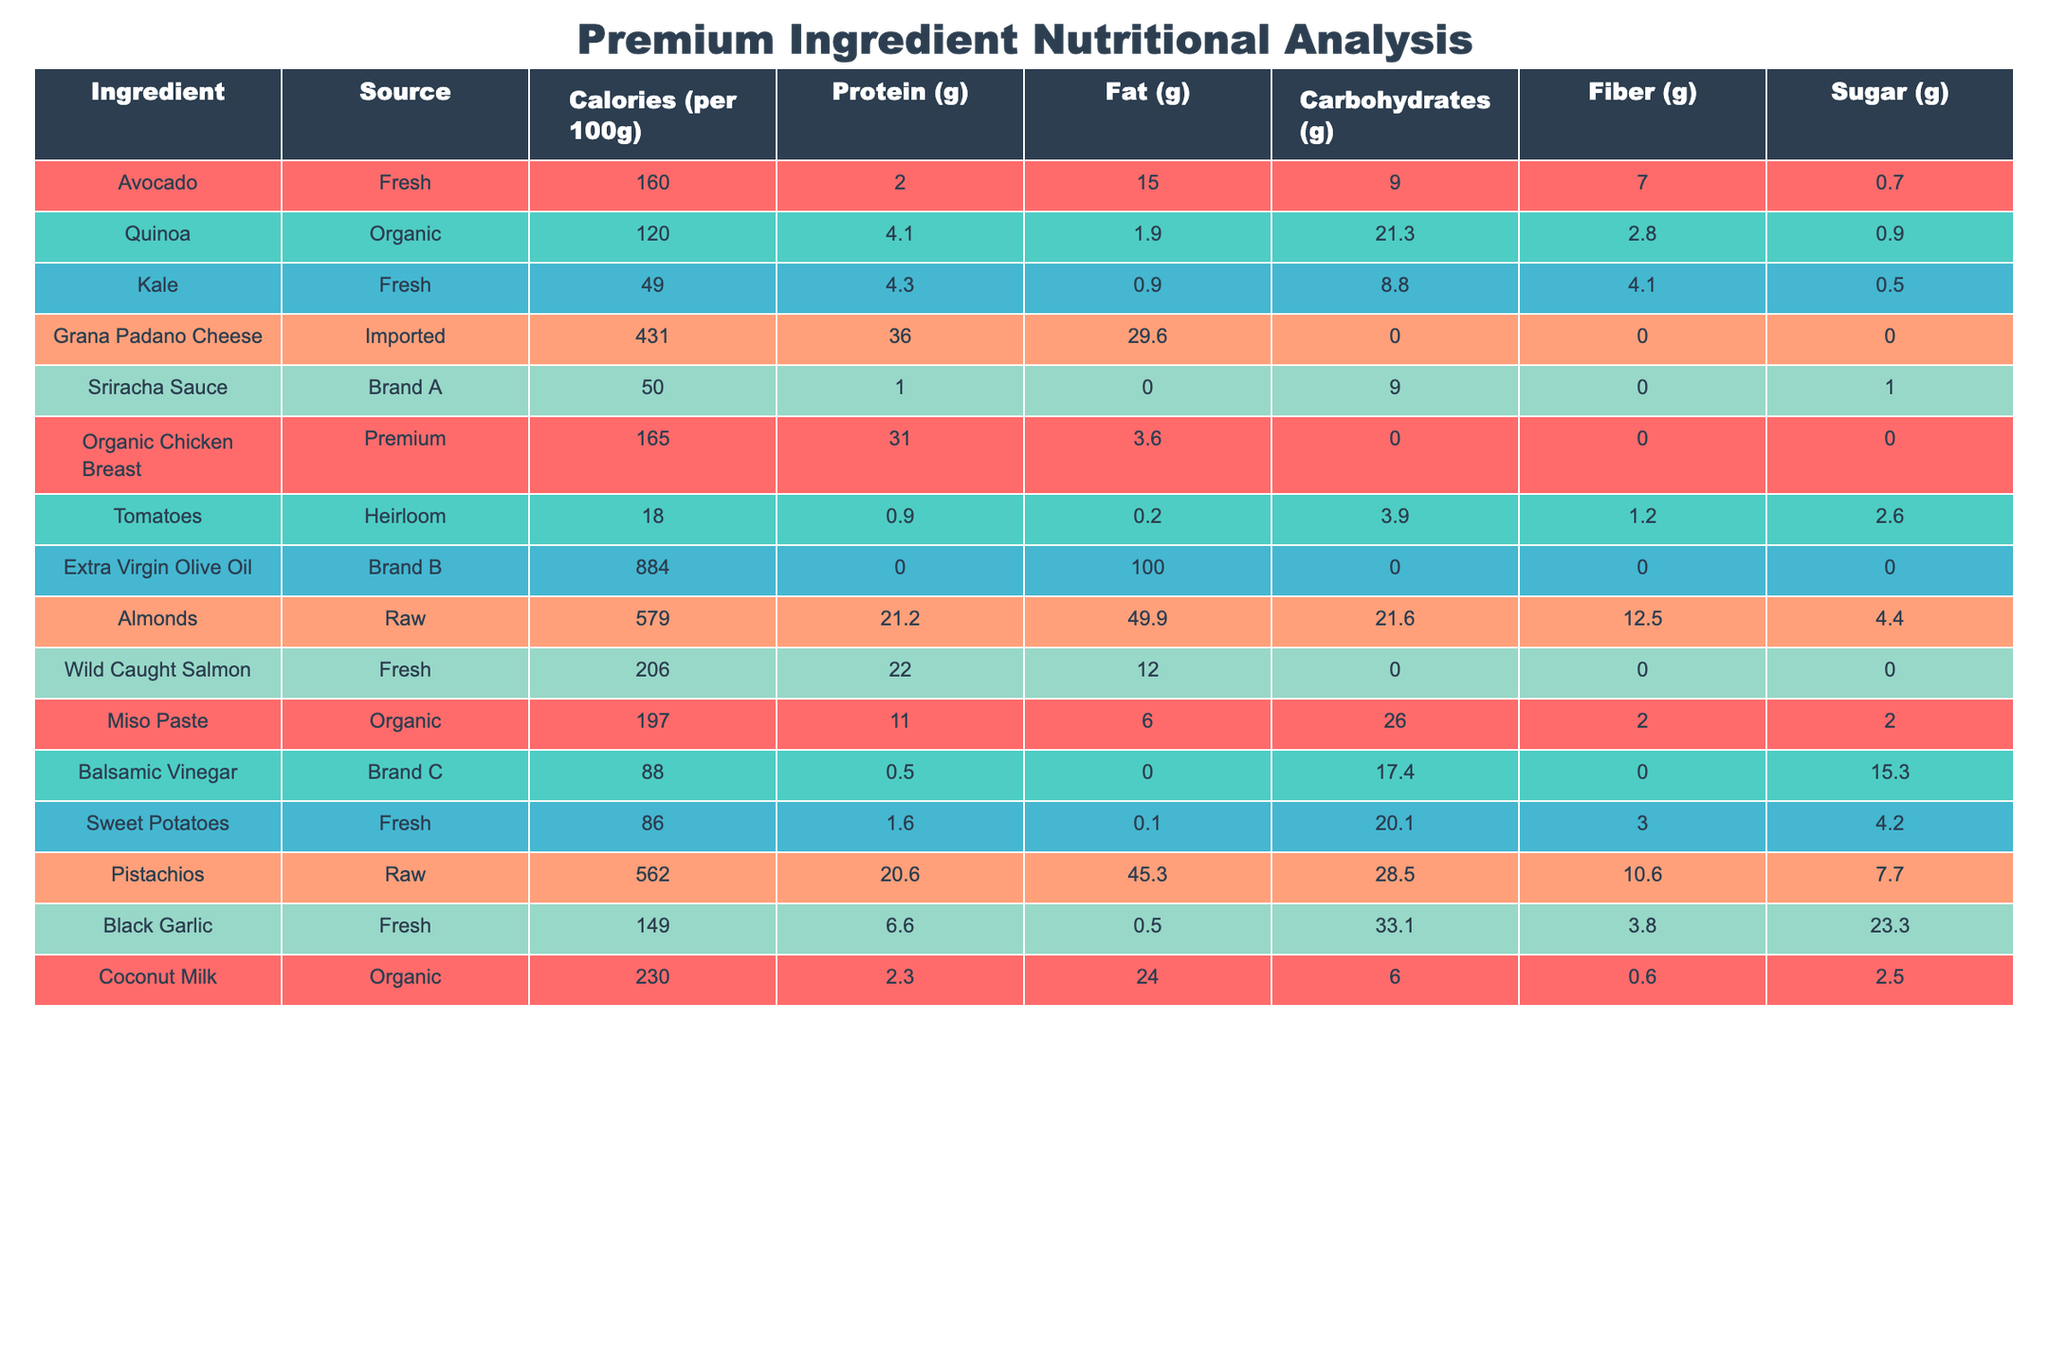What is the ingredient with the highest calorie content? Looking through the "Calories (per 100g)" column, Extra Virgin Olive Oil has the highest value at 884 calories.
Answer: Extra Virgin Olive Oil Which ingredient has the highest protein content? From the "Protein (g)" column, Grana Padano Cheese has the highest protein content at 36 grams per 100g.
Answer: Grana Padano Cheese True or False: Quinoa contains more carbohydrates than sweet potatoes. By checking the "Carbohydrates (g)" column, quinoa has 21.3 grams while sweet potatoes have 20.1 grams, making the statement true.
Answer: True What is the total fat content of almonds and pistachios combined? The fat content for almonds is 49.9 grams and for pistachios it is 45.3 grams. Adding these two gives 49.9 + 45.3 = 95.2 grams of fat.
Answer: 95.2 grams What is the average calorie content of the ingredients listed? To find the average, first sum the calories: 160 + 120 + 49 + 431 + 50 + 165 + 18 + 884 + 579 + 206 + 197 + 88 + 86 + 562 + 230 = 3020 calories. There are 15 ingredients, so the average is 3020 / 15 = 201.33 calories.
Answer: 201.33 calories Which ingredient has the lowest sugar content? Looking at the "Sugar (g)" column, tomatoes have the lowest content at 2.6 grams per 100g.
Answer: Tomatoes How much more fiber does miso paste have compared to kale? Miso paste contains 2 grams of fiber, while kale contains 4.1 grams. The difference is 4.1 - 2 = 2.1 grams more fiber in kale.
Answer: 2.1 grams Is it true that organic chicken breast contains fewer calories than wild-caught salmon? The "Calories (per 100g)" for organic chicken breast is 165, while for wild-caught salmon it is 206, making the statement false.
Answer: False What is the total carbohydrate content for all the ingredients listed? The carbohydrate values are summed as follows: 9 + 21.3 + 8.8 + 0 + 9 + 0 + 3.9 + 0 + 21.6 + 0 + 26 + 17.4 + 20.1 + 28.5 + 6 = 239.6 grams.
Answer: 239.6 grams Identify the ingredient with the least amount of protein. Reviewing the "Protein (g)" column, tomatoes have the least protein at 0.9 grams per 100g.
Answer: Tomatoes 